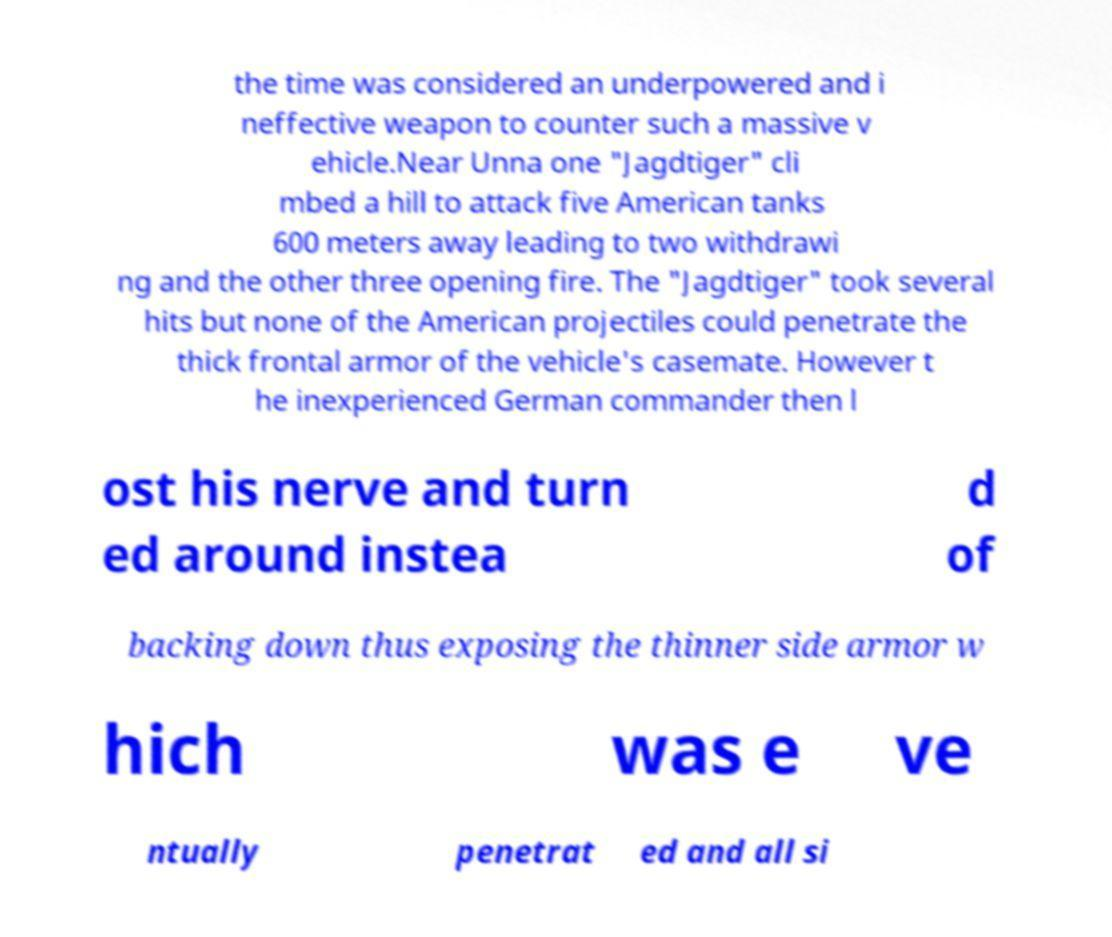Can you read and provide the text displayed in the image?This photo seems to have some interesting text. Can you extract and type it out for me? the time was considered an underpowered and i neffective weapon to counter such a massive v ehicle.Near Unna one "Jagdtiger" cli mbed a hill to attack five American tanks 600 meters away leading to two withdrawi ng and the other three opening fire. The "Jagdtiger" took several hits but none of the American projectiles could penetrate the thick frontal armor of the vehicle's casemate. However t he inexperienced German commander then l ost his nerve and turn ed around instea d of backing down thus exposing the thinner side armor w hich was e ve ntually penetrat ed and all si 